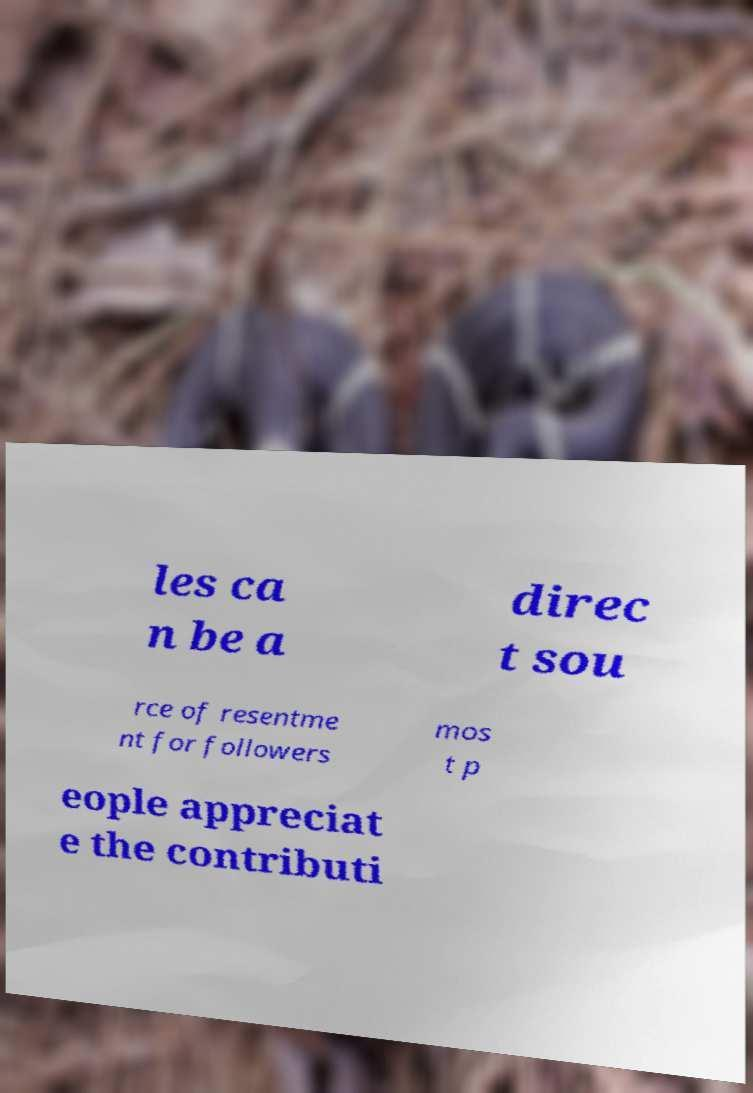There's text embedded in this image that I need extracted. Can you transcribe it verbatim? les ca n be a direc t sou rce of resentme nt for followers mos t p eople appreciat e the contributi 